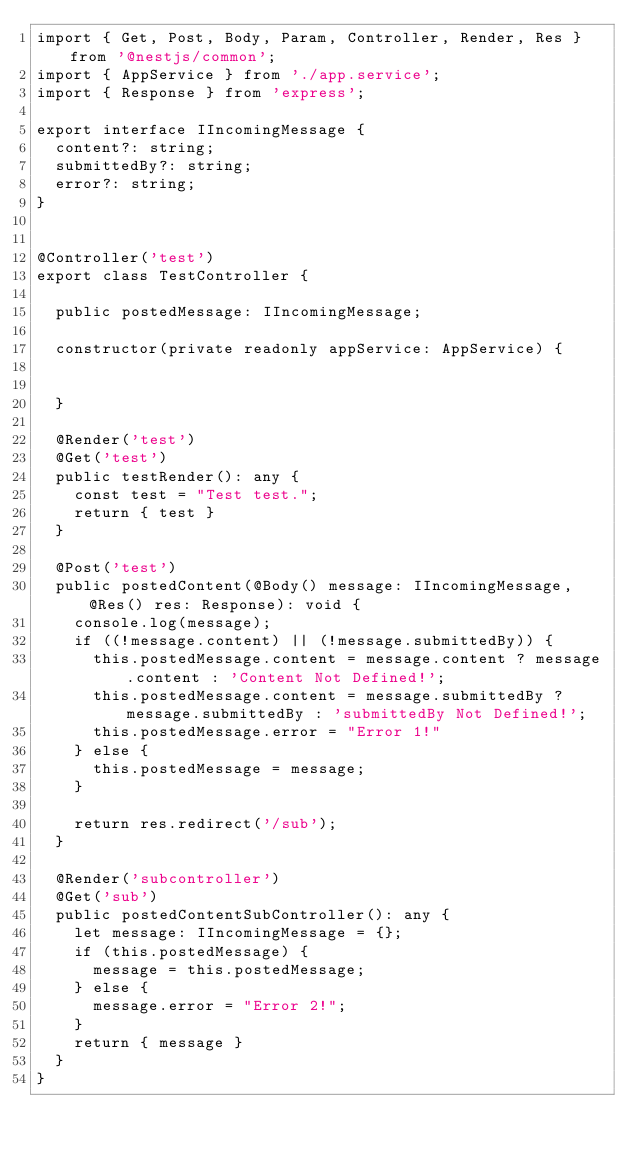<code> <loc_0><loc_0><loc_500><loc_500><_TypeScript_>import { Get, Post, Body, Param, Controller, Render, Res } from '@nestjs/common';
import { AppService } from './app.service';
import { Response } from 'express';

export interface IIncomingMessage {
  content?: string;
  submittedBy?: string;
  error?: string;
}


@Controller('test')
export class TestController {

  public postedMessage: IIncomingMessage;

  constructor(private readonly appService: AppService) {


  }

  @Render('test')
  @Get('test')
  public testRender(): any {
    const test = "Test test.";
    return { test }
  }

  @Post('test')
  public postedContent(@Body() message: IIncomingMessage, @Res() res: Response): void {
    console.log(message);
    if ((!message.content) || (!message.submittedBy)) {
      this.postedMessage.content = message.content ? message.content : 'Content Not Defined!';
      this.postedMessage.content = message.submittedBy ? message.submittedBy : 'submittedBy Not Defined!';
      this.postedMessage.error = "Error 1!"
    } else {
      this.postedMessage = message;
    }

    return res.redirect('/sub');
  }

  @Render('subcontroller')
  @Get('sub')
  public postedContentSubController(): any {
    let message: IIncomingMessage = {};
    if (this.postedMessage) {
      message = this.postedMessage;
    } else {
      message.error = "Error 2!";
    }
    return { message }
  }
}
</code> 